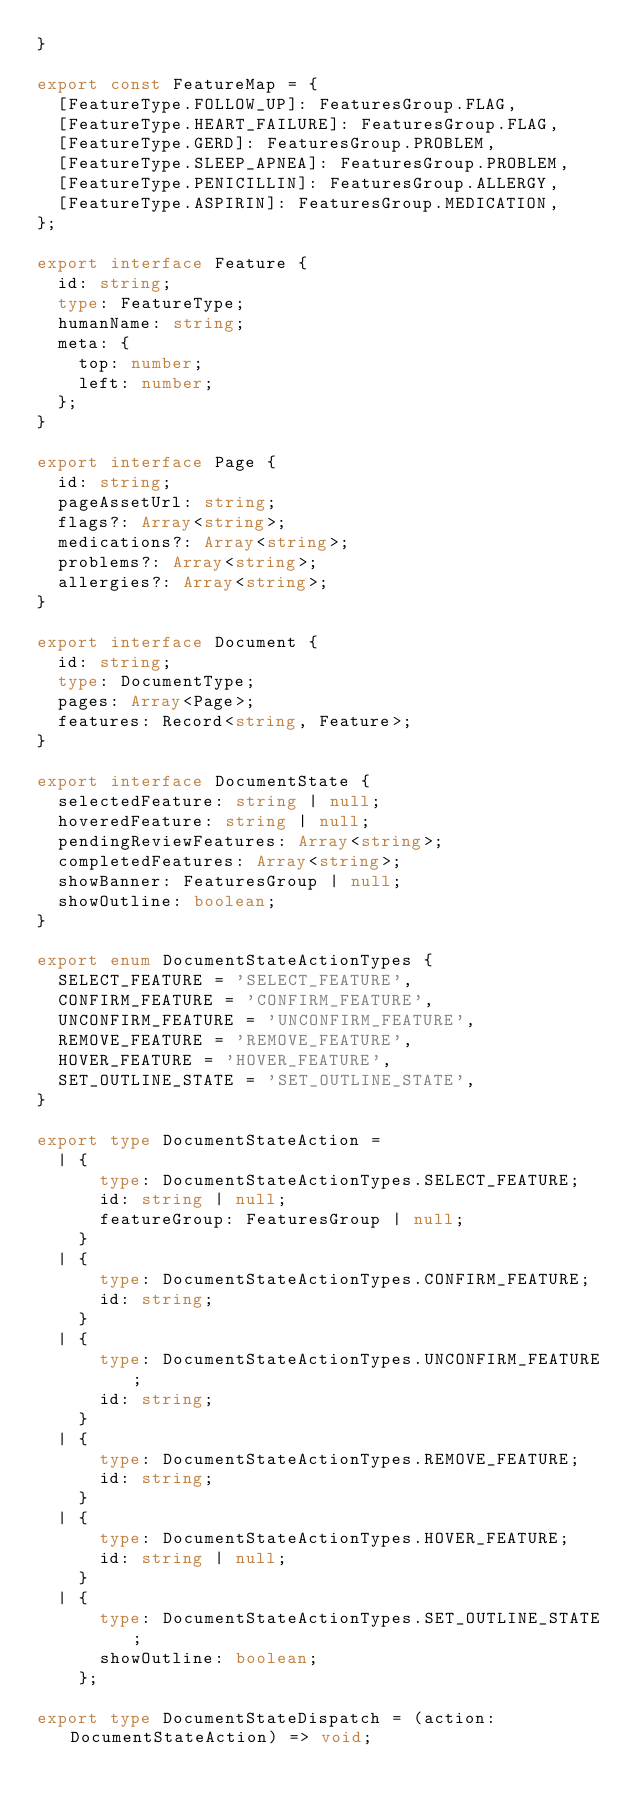<code> <loc_0><loc_0><loc_500><loc_500><_TypeScript_>}

export const FeatureMap = {
  [FeatureType.FOLLOW_UP]: FeaturesGroup.FLAG,
  [FeatureType.HEART_FAILURE]: FeaturesGroup.FLAG,
  [FeatureType.GERD]: FeaturesGroup.PROBLEM,
  [FeatureType.SLEEP_APNEA]: FeaturesGroup.PROBLEM,
  [FeatureType.PENICILLIN]: FeaturesGroup.ALLERGY,
  [FeatureType.ASPIRIN]: FeaturesGroup.MEDICATION,
};

export interface Feature {
  id: string;
  type: FeatureType;
  humanName: string;
  meta: {
    top: number;
    left: number;
  };
}

export interface Page {
  id: string;
  pageAssetUrl: string;
  flags?: Array<string>;
  medications?: Array<string>;
  problems?: Array<string>;
  allergies?: Array<string>;
}

export interface Document {
  id: string;
  type: DocumentType;
  pages: Array<Page>;
  features: Record<string, Feature>;
}

export interface DocumentState {
  selectedFeature: string | null;
  hoveredFeature: string | null;
  pendingReviewFeatures: Array<string>;
  completedFeatures: Array<string>;
  showBanner: FeaturesGroup | null;
  showOutline: boolean;
}

export enum DocumentStateActionTypes {
  SELECT_FEATURE = 'SELECT_FEATURE',
  CONFIRM_FEATURE = 'CONFIRM_FEATURE',
  UNCONFIRM_FEATURE = 'UNCONFIRM_FEATURE',
  REMOVE_FEATURE = 'REMOVE_FEATURE',
  HOVER_FEATURE = 'HOVER_FEATURE',
  SET_OUTLINE_STATE = 'SET_OUTLINE_STATE',
}

export type DocumentStateAction =
  | {
      type: DocumentStateActionTypes.SELECT_FEATURE;
      id: string | null;
      featureGroup: FeaturesGroup | null;
    }
  | {
      type: DocumentStateActionTypes.CONFIRM_FEATURE;
      id: string;
    }
  | {
      type: DocumentStateActionTypes.UNCONFIRM_FEATURE;
      id: string;
    }
  | {
      type: DocumentStateActionTypes.REMOVE_FEATURE;
      id: string;
    }
  | {
      type: DocumentStateActionTypes.HOVER_FEATURE;
      id: string | null;
    }
  | {
      type: DocumentStateActionTypes.SET_OUTLINE_STATE;
      showOutline: boolean;
    };

export type DocumentStateDispatch = (action: DocumentStateAction) => void;
</code> 